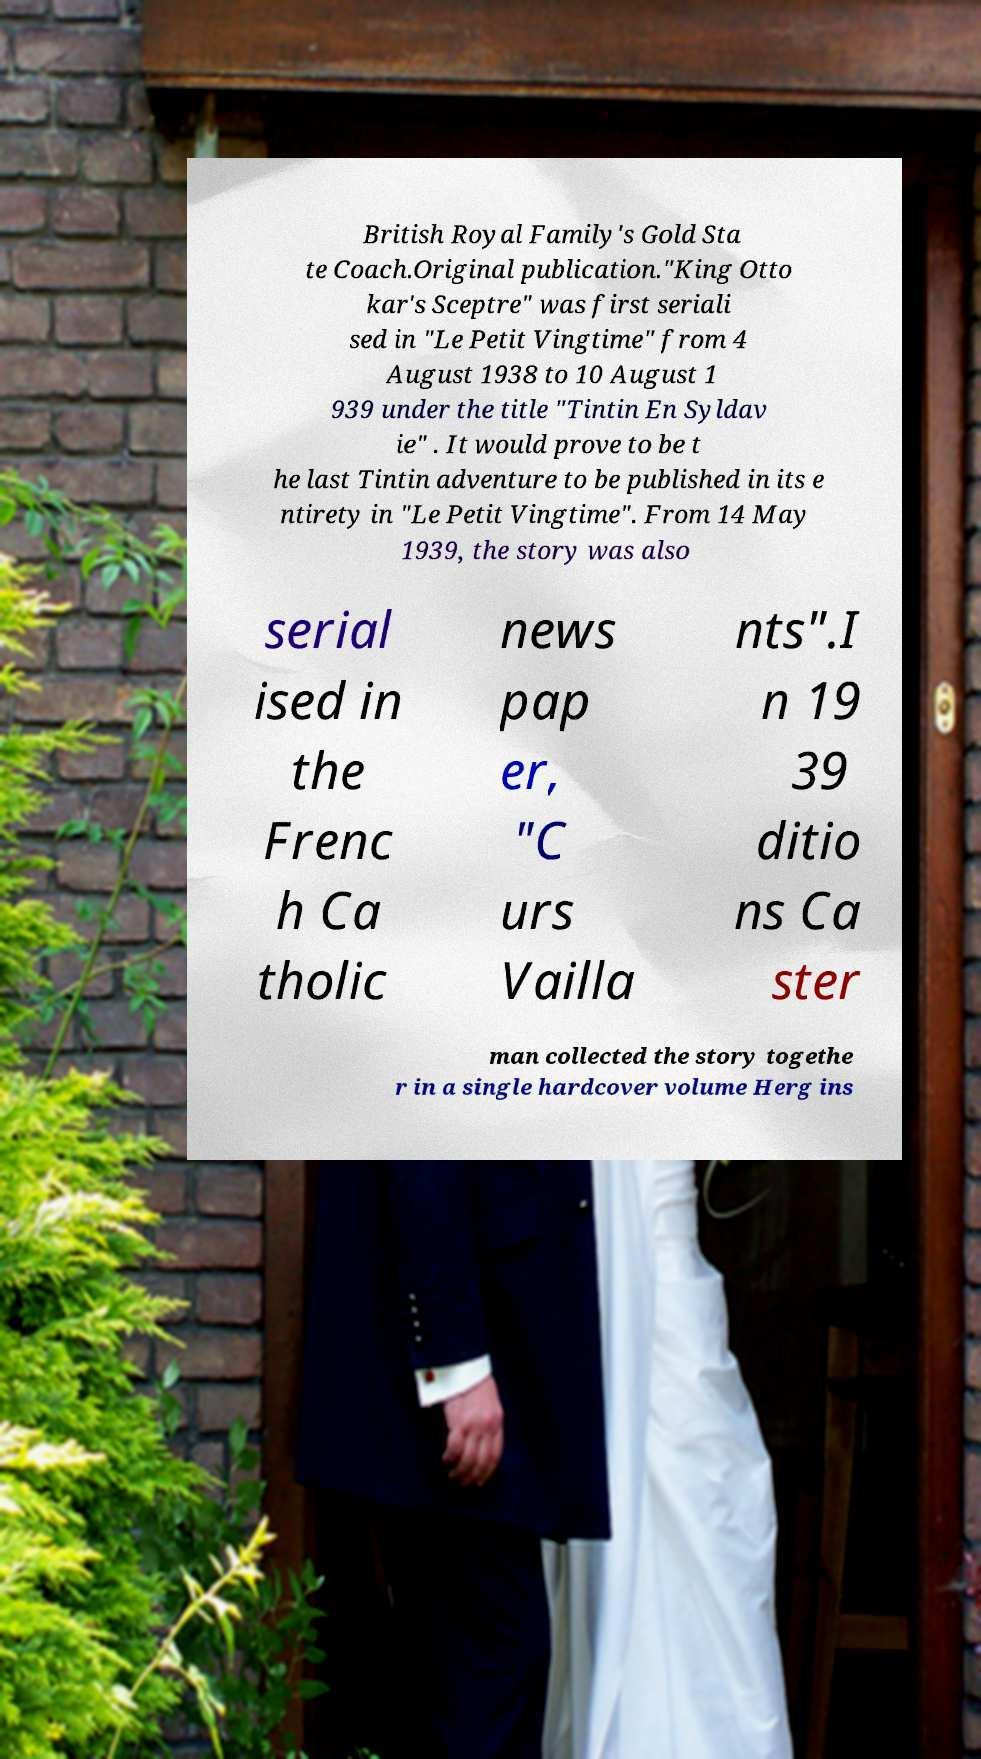Please identify and transcribe the text found in this image. British Royal Family's Gold Sta te Coach.Original publication."King Otto kar's Sceptre" was first seriali sed in "Le Petit Vingtime" from 4 August 1938 to 10 August 1 939 under the title "Tintin En Syldav ie" . It would prove to be t he last Tintin adventure to be published in its e ntirety in "Le Petit Vingtime". From 14 May 1939, the story was also serial ised in the Frenc h Ca tholic news pap er, "C urs Vailla nts".I n 19 39 ditio ns Ca ster man collected the story togethe r in a single hardcover volume Herg ins 